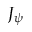<formula> <loc_0><loc_0><loc_500><loc_500>J _ { \psi }</formula> 